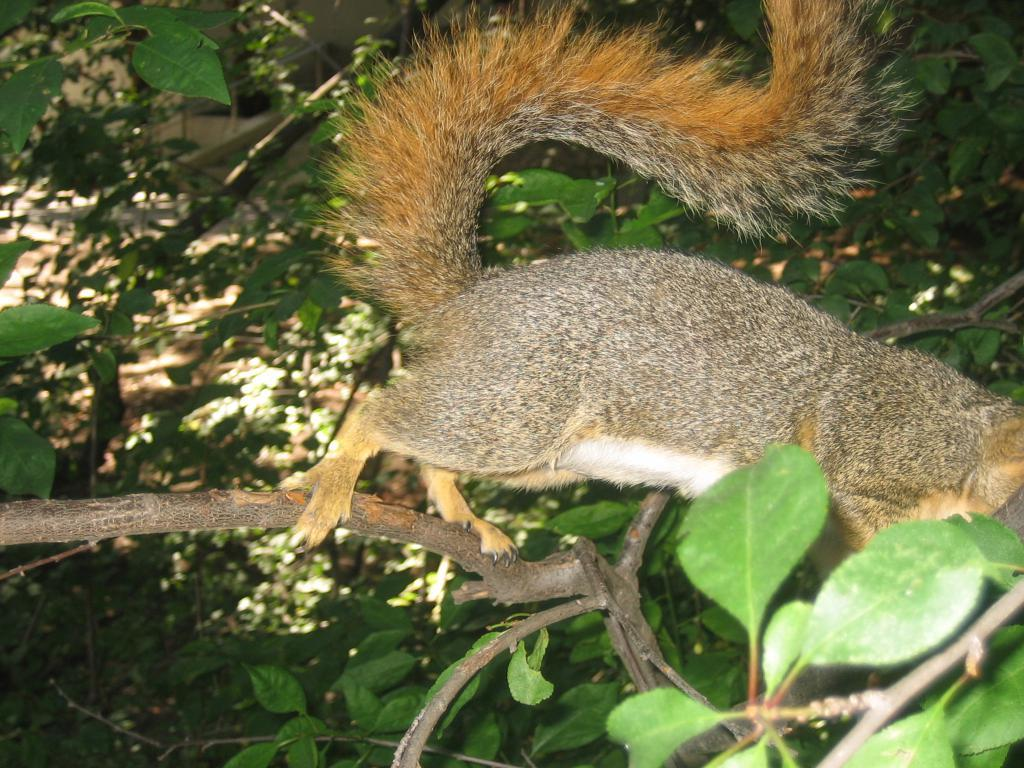What is on a branch of a tree in the image? There is an animal on a branch of a tree in the image. What type of vegetation can be seen in the image? There are plants and trees visible in the image. What type of crook is the animal using to climb the tree in the image? There is no crook present in the image, and the animal is not using any tool to climb the tree. 